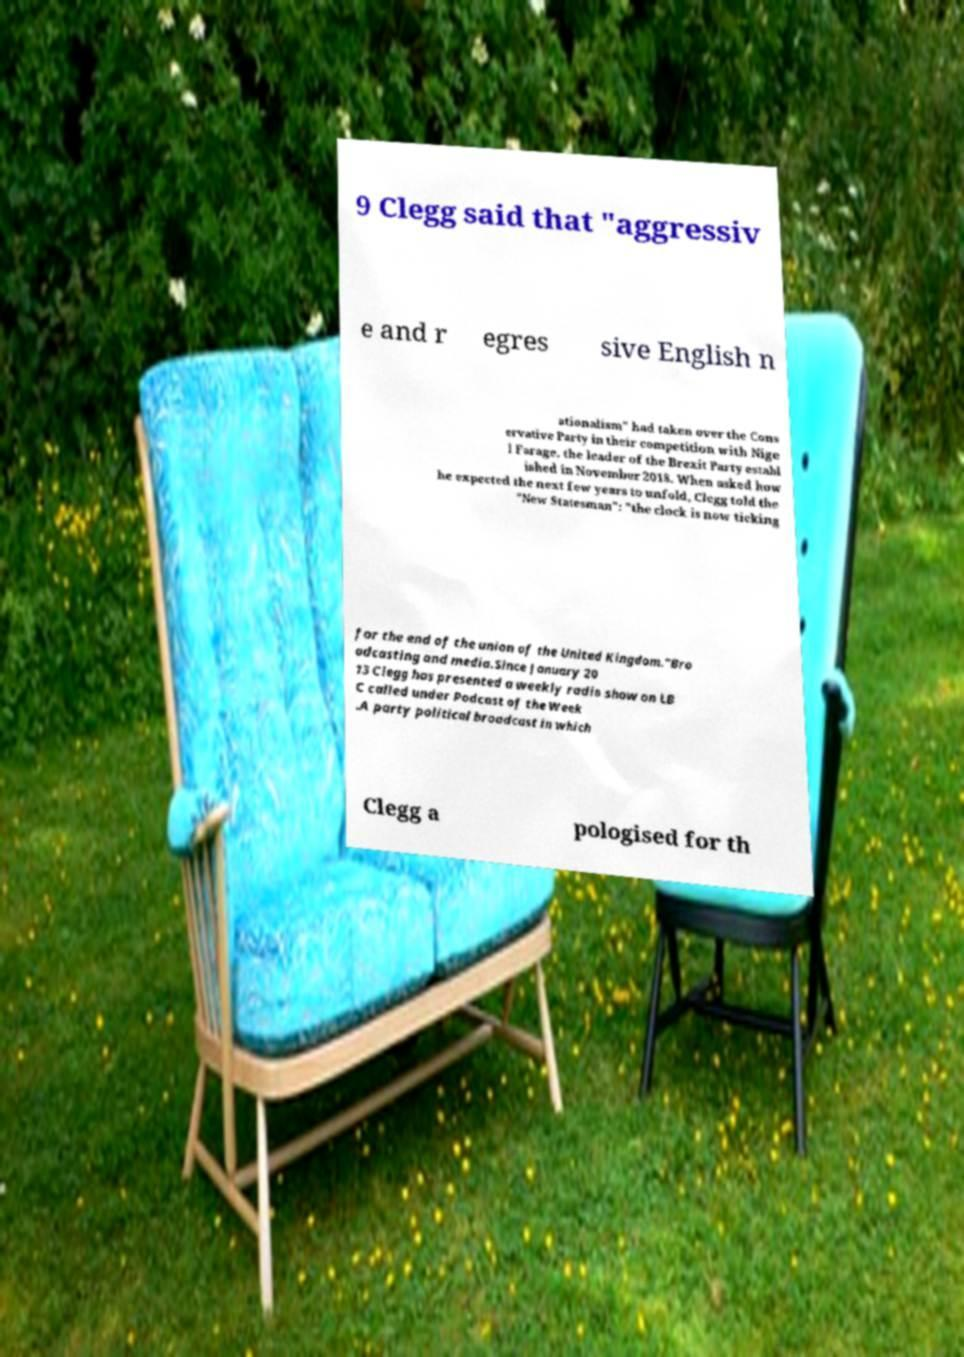I need the written content from this picture converted into text. Can you do that? 9 Clegg said that "aggressiv e and r egres sive English n ationalism" had taken over the Cons ervative Party in their competition with Nige l Farage, the leader of the Brexit Party establ ished in November 2018. When asked how he expected the next few years to unfold, Clegg told the "New Statesman": "the clock is now ticking for the end of the union of the United Kingdom."Bro adcasting and media.Since January 20 13 Clegg has presented a weekly radio show on LB C called under Podcast of the Week .A party political broadcast in which Clegg a pologised for th 